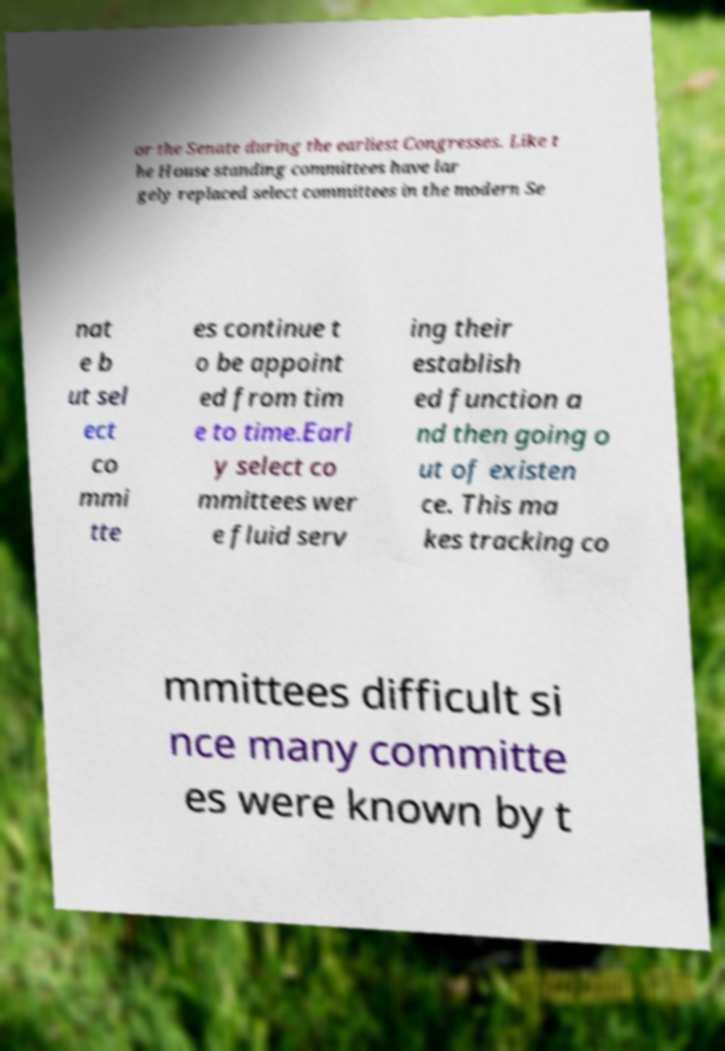Please read and relay the text visible in this image. What does it say? or the Senate during the earliest Congresses. Like t he House standing committees have lar gely replaced select committees in the modern Se nat e b ut sel ect co mmi tte es continue t o be appoint ed from tim e to time.Earl y select co mmittees wer e fluid serv ing their establish ed function a nd then going o ut of existen ce. This ma kes tracking co mmittees difficult si nce many committe es were known by t 